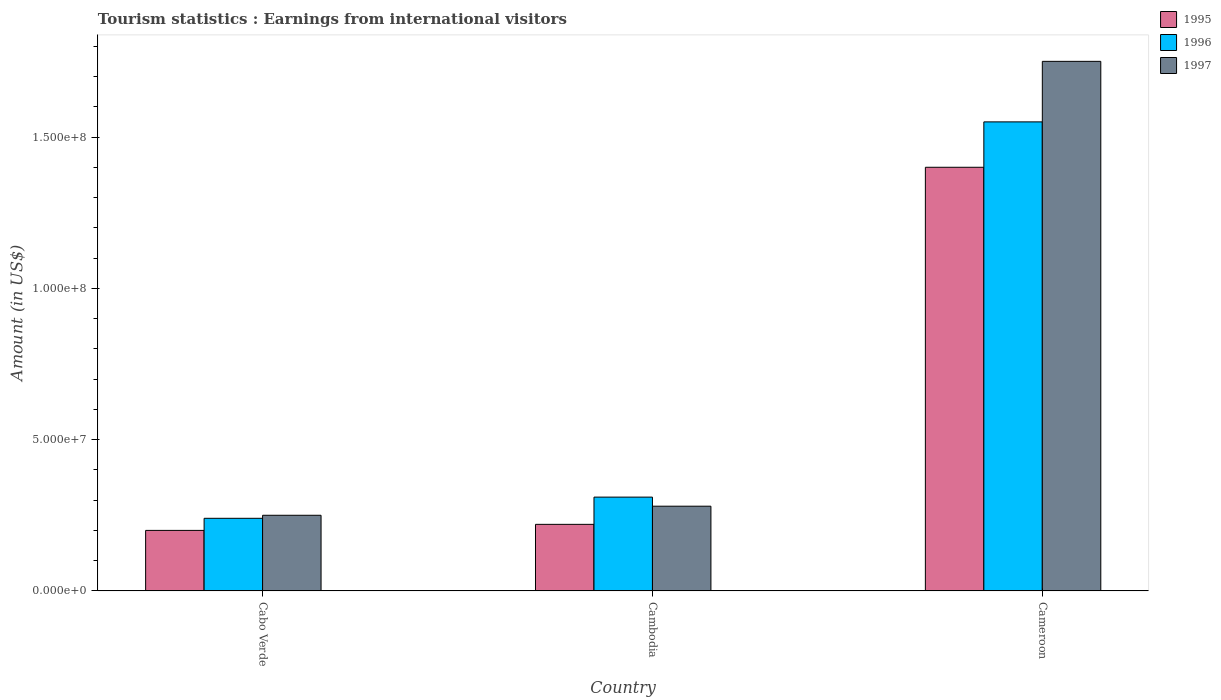How many different coloured bars are there?
Ensure brevity in your answer.  3. How many groups of bars are there?
Make the answer very short. 3. Are the number of bars on each tick of the X-axis equal?
Offer a terse response. Yes. How many bars are there on the 1st tick from the left?
Offer a very short reply. 3. How many bars are there on the 3rd tick from the right?
Keep it short and to the point. 3. What is the label of the 1st group of bars from the left?
Your answer should be compact. Cabo Verde. What is the earnings from international visitors in 1996 in Cambodia?
Your response must be concise. 3.10e+07. Across all countries, what is the maximum earnings from international visitors in 1995?
Offer a very short reply. 1.40e+08. Across all countries, what is the minimum earnings from international visitors in 1997?
Give a very brief answer. 2.50e+07. In which country was the earnings from international visitors in 1995 maximum?
Your answer should be compact. Cameroon. In which country was the earnings from international visitors in 1997 minimum?
Ensure brevity in your answer.  Cabo Verde. What is the total earnings from international visitors in 1996 in the graph?
Provide a short and direct response. 2.10e+08. What is the difference between the earnings from international visitors in 1995 in Cabo Verde and that in Cameroon?
Offer a terse response. -1.20e+08. What is the difference between the earnings from international visitors in 1996 in Cameroon and the earnings from international visitors in 1997 in Cabo Verde?
Offer a very short reply. 1.30e+08. What is the average earnings from international visitors in 1995 per country?
Your answer should be very brief. 6.07e+07. What is the difference between the earnings from international visitors of/in 1997 and earnings from international visitors of/in 1995 in Cambodia?
Offer a very short reply. 6.00e+06. In how many countries, is the earnings from international visitors in 1996 greater than 50000000 US$?
Provide a succinct answer. 1. What is the ratio of the earnings from international visitors in 1997 in Cabo Verde to that in Cambodia?
Keep it short and to the point. 0.89. Is the difference between the earnings from international visitors in 1997 in Cabo Verde and Cambodia greater than the difference between the earnings from international visitors in 1995 in Cabo Verde and Cambodia?
Provide a succinct answer. No. What is the difference between the highest and the second highest earnings from international visitors in 1995?
Provide a short and direct response. 1.20e+08. What is the difference between the highest and the lowest earnings from international visitors in 1997?
Your answer should be very brief. 1.50e+08. In how many countries, is the earnings from international visitors in 1997 greater than the average earnings from international visitors in 1997 taken over all countries?
Your answer should be compact. 1. Is the sum of the earnings from international visitors in 1995 in Cambodia and Cameroon greater than the maximum earnings from international visitors in 1997 across all countries?
Your answer should be very brief. No. What does the 2nd bar from the right in Cameroon represents?
Your answer should be very brief. 1996. Is it the case that in every country, the sum of the earnings from international visitors in 1997 and earnings from international visitors in 1995 is greater than the earnings from international visitors in 1996?
Your answer should be compact. Yes. How many bars are there?
Make the answer very short. 9. Are all the bars in the graph horizontal?
Offer a terse response. No. What is the difference between two consecutive major ticks on the Y-axis?
Give a very brief answer. 5.00e+07. Does the graph contain any zero values?
Your answer should be very brief. No. How many legend labels are there?
Make the answer very short. 3. What is the title of the graph?
Offer a very short reply. Tourism statistics : Earnings from international visitors. Does "2004" appear as one of the legend labels in the graph?
Give a very brief answer. No. What is the label or title of the X-axis?
Offer a terse response. Country. What is the Amount (in US$) of 1996 in Cabo Verde?
Offer a very short reply. 2.40e+07. What is the Amount (in US$) of 1997 in Cabo Verde?
Provide a succinct answer. 2.50e+07. What is the Amount (in US$) in 1995 in Cambodia?
Provide a short and direct response. 2.20e+07. What is the Amount (in US$) of 1996 in Cambodia?
Make the answer very short. 3.10e+07. What is the Amount (in US$) of 1997 in Cambodia?
Keep it short and to the point. 2.80e+07. What is the Amount (in US$) of 1995 in Cameroon?
Offer a terse response. 1.40e+08. What is the Amount (in US$) in 1996 in Cameroon?
Provide a short and direct response. 1.55e+08. What is the Amount (in US$) in 1997 in Cameroon?
Offer a very short reply. 1.75e+08. Across all countries, what is the maximum Amount (in US$) of 1995?
Provide a short and direct response. 1.40e+08. Across all countries, what is the maximum Amount (in US$) of 1996?
Ensure brevity in your answer.  1.55e+08. Across all countries, what is the maximum Amount (in US$) of 1997?
Keep it short and to the point. 1.75e+08. Across all countries, what is the minimum Amount (in US$) in 1995?
Your answer should be very brief. 2.00e+07. Across all countries, what is the minimum Amount (in US$) in 1996?
Your answer should be very brief. 2.40e+07. Across all countries, what is the minimum Amount (in US$) in 1997?
Offer a very short reply. 2.50e+07. What is the total Amount (in US$) of 1995 in the graph?
Provide a short and direct response. 1.82e+08. What is the total Amount (in US$) of 1996 in the graph?
Ensure brevity in your answer.  2.10e+08. What is the total Amount (in US$) in 1997 in the graph?
Your answer should be compact. 2.28e+08. What is the difference between the Amount (in US$) of 1995 in Cabo Verde and that in Cambodia?
Provide a short and direct response. -2.00e+06. What is the difference between the Amount (in US$) in 1996 in Cabo Verde and that in Cambodia?
Your answer should be compact. -7.00e+06. What is the difference between the Amount (in US$) of 1997 in Cabo Verde and that in Cambodia?
Make the answer very short. -3.00e+06. What is the difference between the Amount (in US$) in 1995 in Cabo Verde and that in Cameroon?
Your answer should be compact. -1.20e+08. What is the difference between the Amount (in US$) in 1996 in Cabo Verde and that in Cameroon?
Provide a short and direct response. -1.31e+08. What is the difference between the Amount (in US$) of 1997 in Cabo Verde and that in Cameroon?
Offer a very short reply. -1.50e+08. What is the difference between the Amount (in US$) in 1995 in Cambodia and that in Cameroon?
Make the answer very short. -1.18e+08. What is the difference between the Amount (in US$) of 1996 in Cambodia and that in Cameroon?
Provide a short and direct response. -1.24e+08. What is the difference between the Amount (in US$) in 1997 in Cambodia and that in Cameroon?
Make the answer very short. -1.47e+08. What is the difference between the Amount (in US$) of 1995 in Cabo Verde and the Amount (in US$) of 1996 in Cambodia?
Your answer should be compact. -1.10e+07. What is the difference between the Amount (in US$) in 1995 in Cabo Verde and the Amount (in US$) in 1997 in Cambodia?
Offer a very short reply. -8.00e+06. What is the difference between the Amount (in US$) of 1996 in Cabo Verde and the Amount (in US$) of 1997 in Cambodia?
Offer a terse response. -4.00e+06. What is the difference between the Amount (in US$) in 1995 in Cabo Verde and the Amount (in US$) in 1996 in Cameroon?
Provide a succinct answer. -1.35e+08. What is the difference between the Amount (in US$) in 1995 in Cabo Verde and the Amount (in US$) in 1997 in Cameroon?
Offer a terse response. -1.55e+08. What is the difference between the Amount (in US$) of 1996 in Cabo Verde and the Amount (in US$) of 1997 in Cameroon?
Provide a succinct answer. -1.51e+08. What is the difference between the Amount (in US$) of 1995 in Cambodia and the Amount (in US$) of 1996 in Cameroon?
Ensure brevity in your answer.  -1.33e+08. What is the difference between the Amount (in US$) in 1995 in Cambodia and the Amount (in US$) in 1997 in Cameroon?
Ensure brevity in your answer.  -1.53e+08. What is the difference between the Amount (in US$) of 1996 in Cambodia and the Amount (in US$) of 1997 in Cameroon?
Offer a very short reply. -1.44e+08. What is the average Amount (in US$) in 1995 per country?
Offer a terse response. 6.07e+07. What is the average Amount (in US$) of 1996 per country?
Keep it short and to the point. 7.00e+07. What is the average Amount (in US$) in 1997 per country?
Offer a terse response. 7.60e+07. What is the difference between the Amount (in US$) in 1995 and Amount (in US$) in 1997 in Cabo Verde?
Your answer should be compact. -5.00e+06. What is the difference between the Amount (in US$) of 1996 and Amount (in US$) of 1997 in Cabo Verde?
Keep it short and to the point. -1.00e+06. What is the difference between the Amount (in US$) in 1995 and Amount (in US$) in 1996 in Cambodia?
Provide a succinct answer. -9.00e+06. What is the difference between the Amount (in US$) in 1995 and Amount (in US$) in 1997 in Cambodia?
Your answer should be compact. -6.00e+06. What is the difference between the Amount (in US$) of 1996 and Amount (in US$) of 1997 in Cambodia?
Keep it short and to the point. 3.00e+06. What is the difference between the Amount (in US$) in 1995 and Amount (in US$) in 1996 in Cameroon?
Offer a very short reply. -1.50e+07. What is the difference between the Amount (in US$) in 1995 and Amount (in US$) in 1997 in Cameroon?
Give a very brief answer. -3.50e+07. What is the difference between the Amount (in US$) of 1996 and Amount (in US$) of 1997 in Cameroon?
Provide a short and direct response. -2.00e+07. What is the ratio of the Amount (in US$) of 1996 in Cabo Verde to that in Cambodia?
Offer a very short reply. 0.77. What is the ratio of the Amount (in US$) of 1997 in Cabo Verde to that in Cambodia?
Give a very brief answer. 0.89. What is the ratio of the Amount (in US$) of 1995 in Cabo Verde to that in Cameroon?
Your answer should be very brief. 0.14. What is the ratio of the Amount (in US$) of 1996 in Cabo Verde to that in Cameroon?
Your answer should be compact. 0.15. What is the ratio of the Amount (in US$) of 1997 in Cabo Verde to that in Cameroon?
Your answer should be very brief. 0.14. What is the ratio of the Amount (in US$) in 1995 in Cambodia to that in Cameroon?
Make the answer very short. 0.16. What is the ratio of the Amount (in US$) in 1997 in Cambodia to that in Cameroon?
Keep it short and to the point. 0.16. What is the difference between the highest and the second highest Amount (in US$) in 1995?
Make the answer very short. 1.18e+08. What is the difference between the highest and the second highest Amount (in US$) of 1996?
Your answer should be compact. 1.24e+08. What is the difference between the highest and the second highest Amount (in US$) of 1997?
Offer a terse response. 1.47e+08. What is the difference between the highest and the lowest Amount (in US$) in 1995?
Offer a terse response. 1.20e+08. What is the difference between the highest and the lowest Amount (in US$) of 1996?
Offer a very short reply. 1.31e+08. What is the difference between the highest and the lowest Amount (in US$) in 1997?
Ensure brevity in your answer.  1.50e+08. 